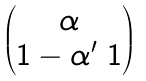<formula> <loc_0><loc_0><loc_500><loc_500>\begin{pmatrix} \alpha \\ 1 - \alpha ^ { \prime } \ 1 \end{pmatrix}</formula> 